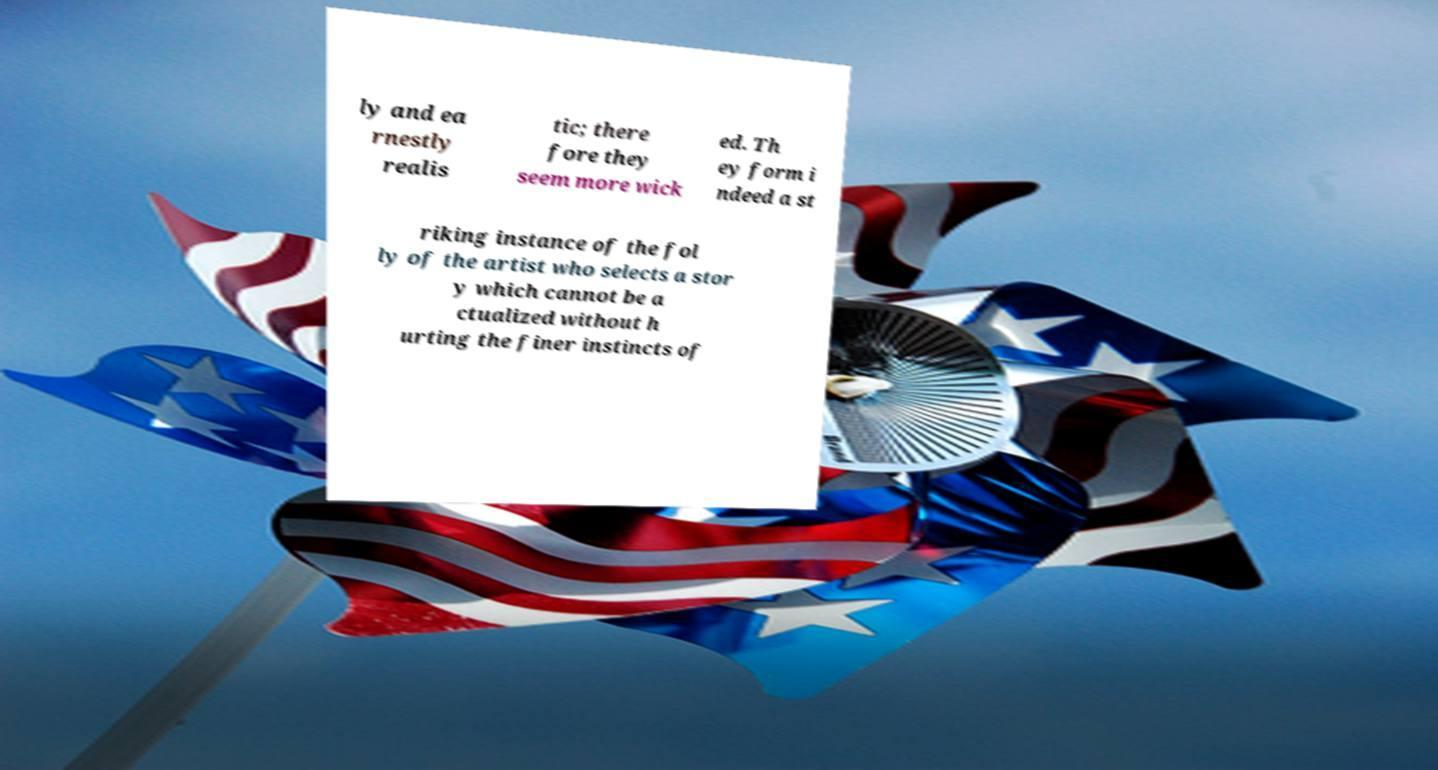Could you assist in decoding the text presented in this image and type it out clearly? ly and ea rnestly realis tic; there fore they seem more wick ed. Th ey form i ndeed a st riking instance of the fol ly of the artist who selects a stor y which cannot be a ctualized without h urting the finer instincts of 